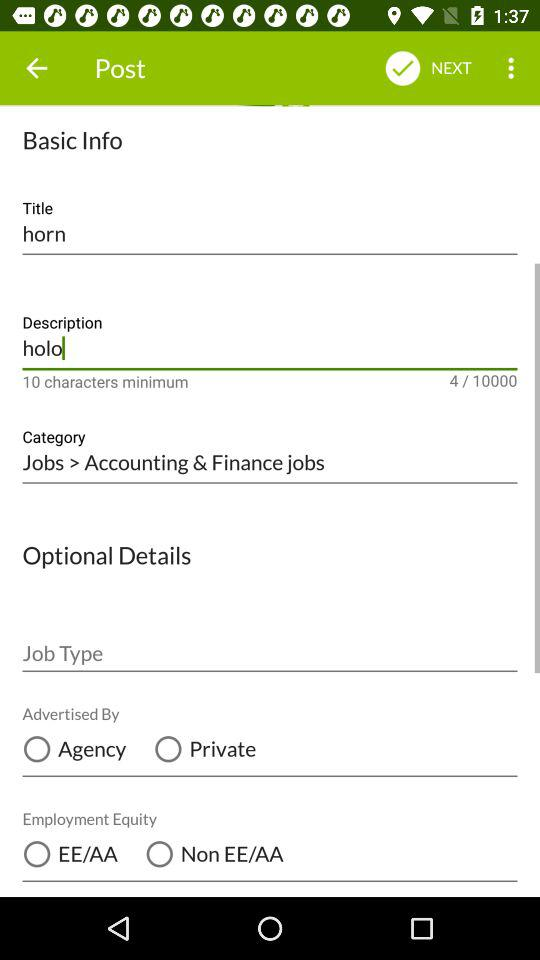How many text inputs are there for the title and description fields?
Answer the question using a single word or phrase. 2 